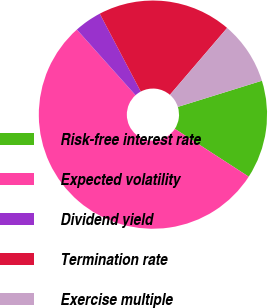Convert chart to OTSL. <chart><loc_0><loc_0><loc_500><loc_500><pie_chart><fcel>Risk-free interest rate<fcel>Expected volatility<fcel>Dividend yield<fcel>Termination rate<fcel>Exercise multiple<nl><fcel>13.95%<fcel>54.24%<fcel>3.9%<fcel>18.98%<fcel>8.93%<nl></chart> 